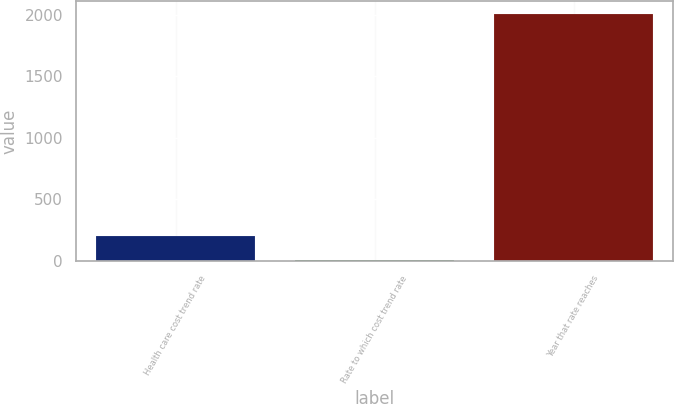<chart> <loc_0><loc_0><loc_500><loc_500><bar_chart><fcel>Health care cost trend rate<fcel>Rate to which cost trend rate<fcel>Year that rate reaches<nl><fcel>205.5<fcel>5<fcel>2010<nl></chart> 